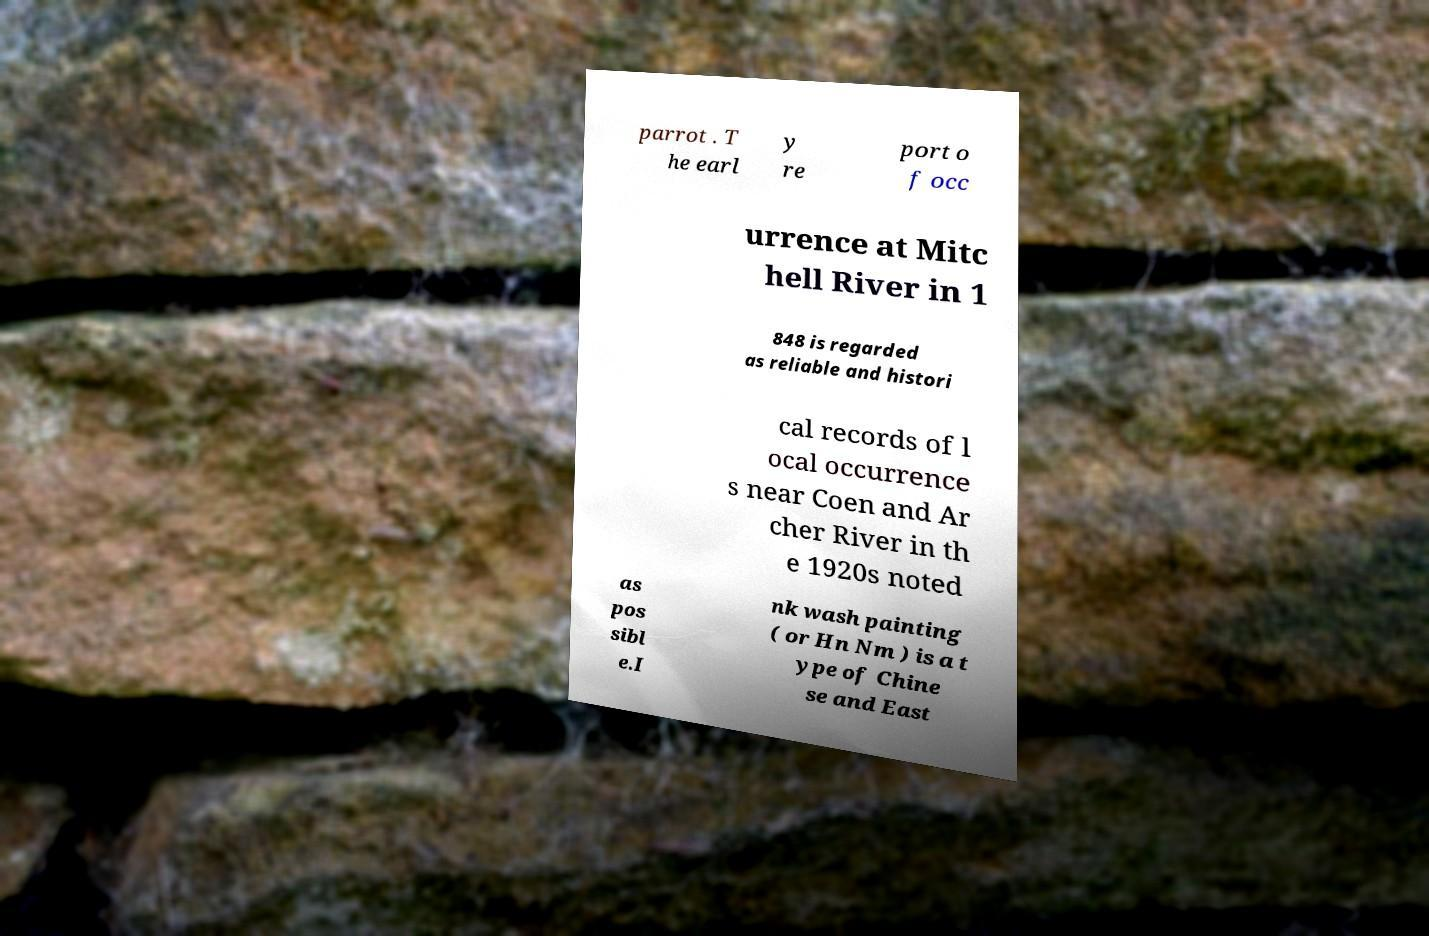Can you accurately transcribe the text from the provided image for me? parrot . T he earl y re port o f occ urrence at Mitc hell River in 1 848 is regarded as reliable and histori cal records of l ocal occurrence s near Coen and Ar cher River in th e 1920s noted as pos sibl e.I nk wash painting ( or Hn Nm ) is a t ype of Chine se and East 